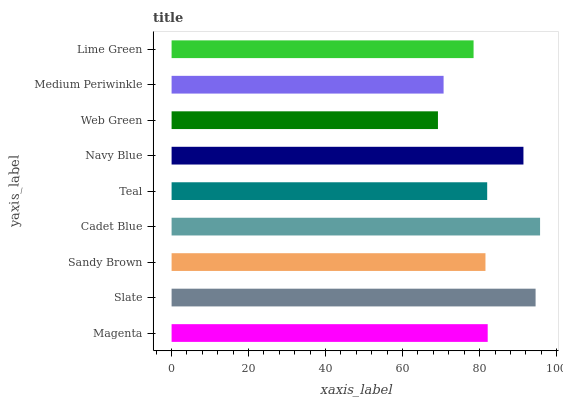Is Web Green the minimum?
Answer yes or no. Yes. Is Cadet Blue the maximum?
Answer yes or no. Yes. Is Slate the minimum?
Answer yes or no. No. Is Slate the maximum?
Answer yes or no. No. Is Slate greater than Magenta?
Answer yes or no. Yes. Is Magenta less than Slate?
Answer yes or no. Yes. Is Magenta greater than Slate?
Answer yes or no. No. Is Slate less than Magenta?
Answer yes or no. No. Is Teal the high median?
Answer yes or no. Yes. Is Teal the low median?
Answer yes or no. Yes. Is Slate the high median?
Answer yes or no. No. Is Slate the low median?
Answer yes or no. No. 